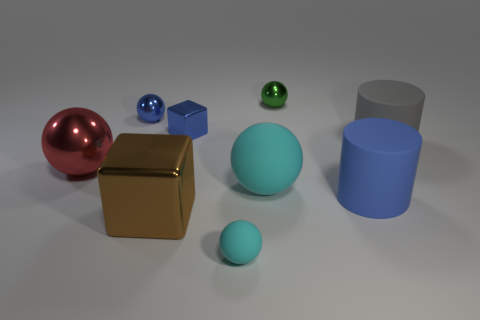What material is the large cylinder in front of the red object?
Provide a succinct answer. Rubber. Are there any large blue things behind the blue thing in front of the red shiny ball?
Your response must be concise. No. Are the blue object right of the green shiny sphere and the gray object made of the same material?
Give a very brief answer. Yes. How many metal objects are both behind the big cyan matte ball and to the right of the tiny blue shiny ball?
Make the answer very short. 2. How many large cubes have the same material as the large red ball?
Make the answer very short. 1. There is a cylinder that is the same material as the large blue thing; what color is it?
Offer a very short reply. Gray. Is the number of metal cubes less than the number of tiny blue spheres?
Offer a terse response. No. There is a big cylinder on the right side of the rubber cylinder that is in front of the sphere that is to the left of the blue ball; what is its material?
Make the answer very short. Rubber. What is the material of the small block?
Provide a short and direct response. Metal. There is a big sphere that is to the right of the small blue metal ball; is its color the same as the rubber ball in front of the blue matte cylinder?
Your answer should be compact. Yes. 